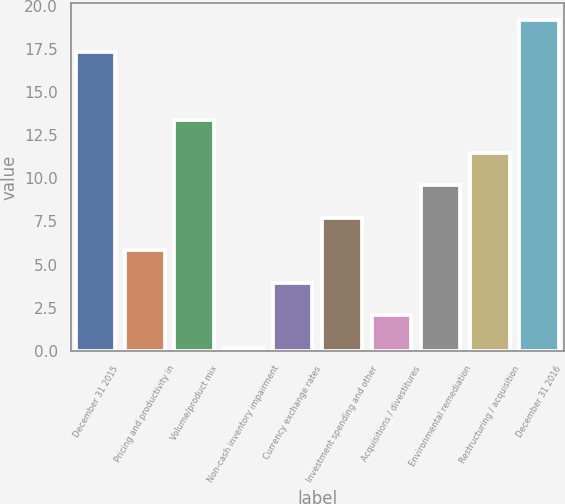<chart> <loc_0><loc_0><loc_500><loc_500><bar_chart><fcel>December 31 2015<fcel>Pricing and productivity in<fcel>Volume/product mix<fcel>Non-cash inventory impairment<fcel>Currency exchange rates<fcel>Investment spending and other<fcel>Acquisitions / divestitures<fcel>Environmental remediation<fcel>Restructuring / acquisition<fcel>December 31 2016<nl><fcel>17.3<fcel>5.84<fcel>13.36<fcel>0.2<fcel>3.96<fcel>7.72<fcel>2.08<fcel>9.6<fcel>11.48<fcel>19.18<nl></chart> 